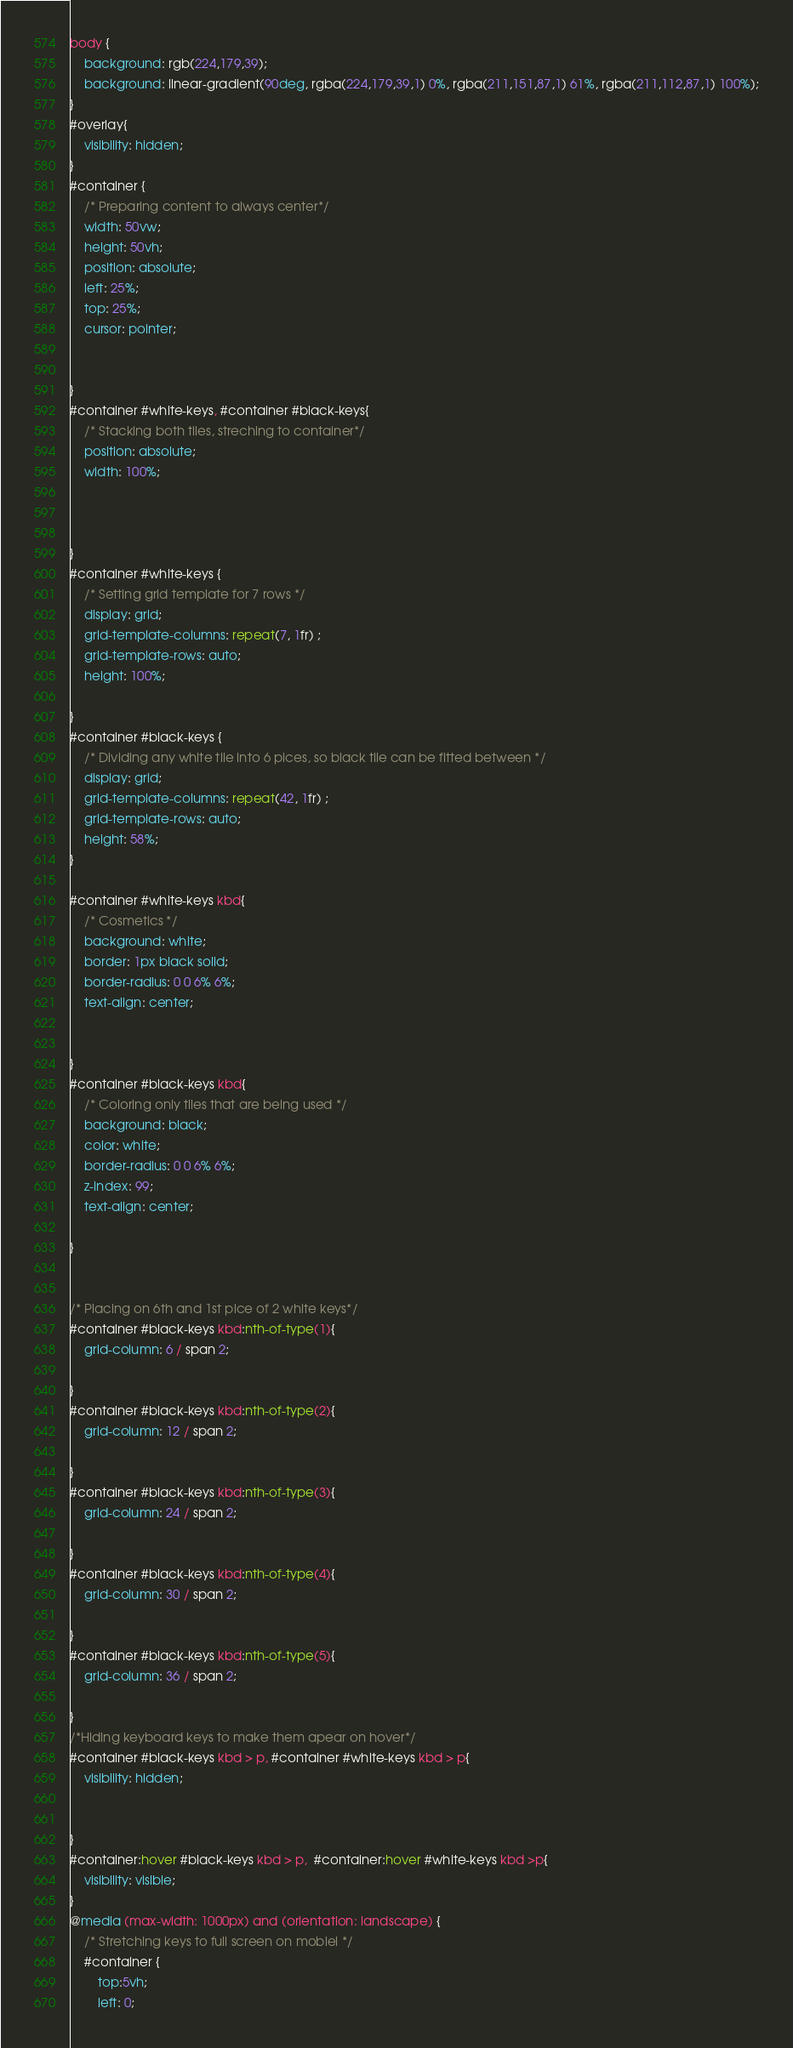<code> <loc_0><loc_0><loc_500><loc_500><_CSS_>body {
    background: rgb(224,179,39);
    background: linear-gradient(90deg, rgba(224,179,39,1) 0%, rgba(211,151,87,1) 61%, rgba(211,112,87,1) 100%);
}
#overlay{
    visibility: hidden;
}
#container {
    /* Preparing content to always center*/
    width: 50vw;
    height: 50vh;
    position: absolute;
    left: 25%;
    top: 25%;
    cursor: pointer;
    
   
}
#container #white-keys, #container #black-keys{
    /* Stacking both tiles, streching to container*/
    position: absolute;
    width: 100%;
    


}
#container #white-keys {
    /* Setting grid template for 7 rows */
    display: grid;
    grid-template-columns: repeat(7, 1fr) ;
    grid-template-rows: auto;
    height: 100%;
    
}
#container #black-keys {
    /* Dividing any white tile into 6 pices, so black tile can be fitted between */
    display: grid;
    grid-template-columns: repeat(42, 1fr) ;
    grid-template-rows: auto;
    height: 58%;
}

#container #white-keys kbd{
    /* Cosmetics */
    background: white;
    border: 1px black solid;
    border-radius: 0 0 6% 6%;
    text-align: center;
    

}
#container #black-keys kbd{
    /* Coloring only tiles that are being used */
    background: black;
    color: white;
    border-radius: 0 0 6% 6%;
    z-index: 99;
    text-align: center;

}


/* Placing on 6th and 1st pice of 2 white keys*/
#container #black-keys kbd:nth-of-type(1){
    grid-column: 6 / span 2;
    
}
#container #black-keys kbd:nth-of-type(2){
    grid-column: 12 / span 2;
    
}
#container #black-keys kbd:nth-of-type(3){
    grid-column: 24 / span 2;
    
}
#container #black-keys kbd:nth-of-type(4){
    grid-column: 30 / span 2;
    
}
#container #black-keys kbd:nth-of-type(5){
    grid-column: 36 / span 2;
    
}
/*Hiding keyboard keys to make them apear on hover*/
#container #black-keys kbd > p, #container #white-keys kbd > p{
    visibility: hidden;
    

}
#container:hover #black-keys kbd > p,  #container:hover #white-keys kbd >p{
    visibility: visible;
}
@media (max-width: 1000px) and (orientation: landscape) {
    /* Stretching keys to full screen on mobiel */
    #container {
        top:5vh;
        left: 0;</code> 